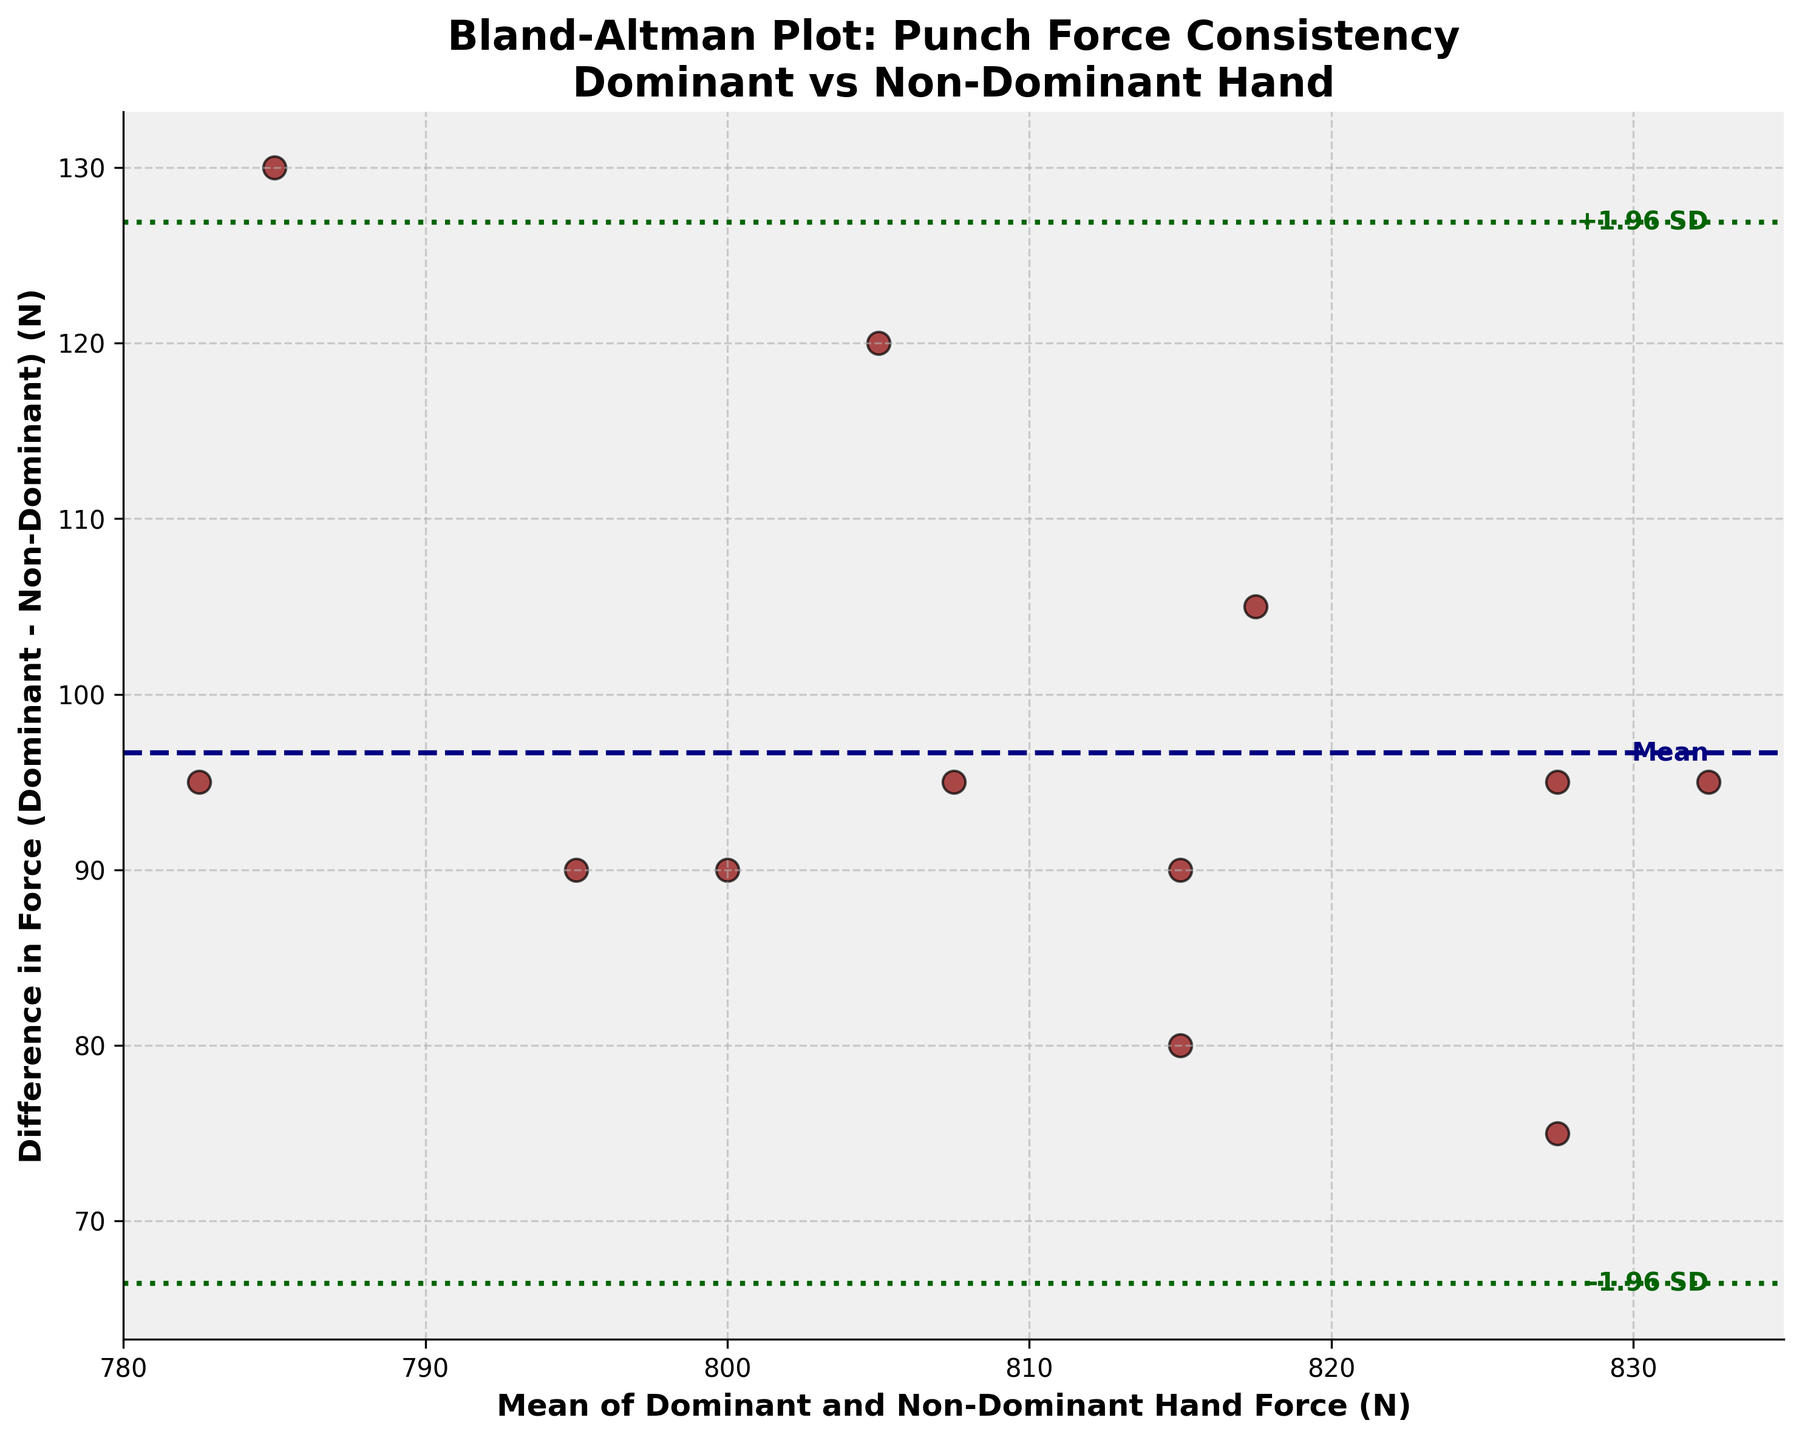What is the title of the figure? The title of the figure as shown at the top of the plot provides context to the data being represented.
Answer: Bland-Altman Plot: Punch Force Consistency Dominant vs Non-Dominant Hand How many data points are plotted on the figure? By counting each data point (scatter dot) on the figure, we can determine the total number.
Answer: 12 What is the mean difference between the dominant and non-dominant hand force? The mean difference is shown by the dark blue dashed line labeled as "Mean" in the figure.
Answer: Approximately 98.33 What do the green dotted lines represent? The green dotted lines represent the limits of agreement which are calculated as the mean difference ± 1.96 times the standard deviation of the differences.
Answer: Limits of agreement What is the range of the y-axis? The range of the y-axis can be determined by looking at the lowest and highest values displayed on the vertical axis.
Answer: -20 to 140 How is the consistency between dominant and non-dominant hand force measured? Consistency is measured by comparing the differences and limits of agreement around the mean difference on the Bland-Altman plot. Data points consistently close to the mean line indicate better agreement.
Answer: By the difference between forces and limits of agreement Are there any data points outside the limits of agreement? By checking the placement of data points in relation to the green dotted lines, we can see if any lie outside these thresholds.
Answer: No Which session had the largest punch force difference between hands? By finding the data point that is furthest from the mean line (difference axis), we can identify the session with the largest force difference.
Answer: Saturday Morning What does it indicate if the majority of the data points are close to the mean difference line? Data points close to the mean difference line indicate a small variation between dominant and non-dominant hand forces, suggesting better consistency.
Answer: Small variation and better consistency 